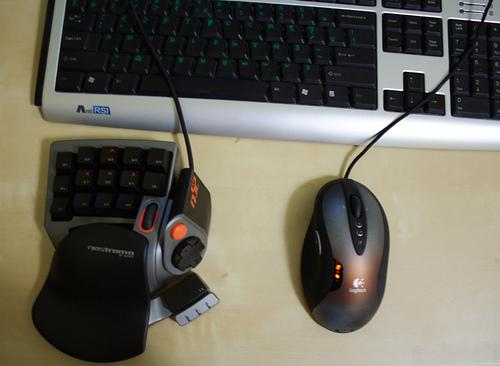What letters/numbers appear on the keyboard at the bottom left?
Be succinct. Rs 1. What brand is the mouse?
Keep it brief. Logitech. Is it likely this photographer disdains technology?
Be succinct. No. What color is this mouse?
Give a very brief answer. Black. What color is the mouse?
Short answer required. Gray. 